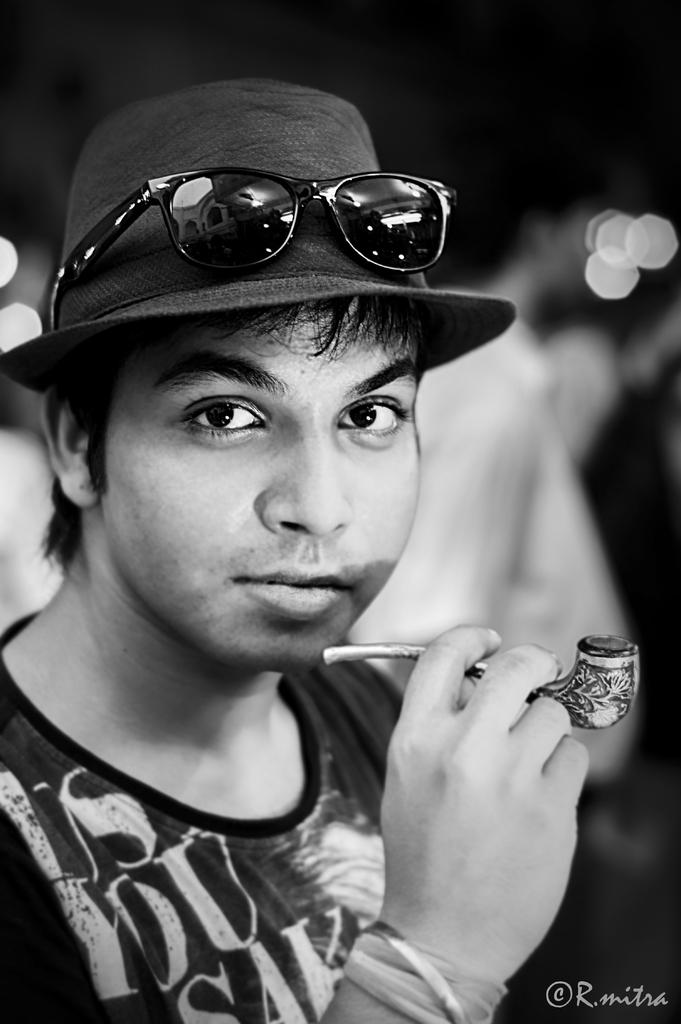Who is present in the image? There is a man in the image. What is the man wearing that is noticeable? The man is wearing black color goggles. What is the man holding in his hand? The man is holding something in his hand. How would you describe the background of the image? The background of the image has black and white colors. What scientific verse is the man reciting in the image? There is no indication in the image that the man is reciting any scientific verses. 